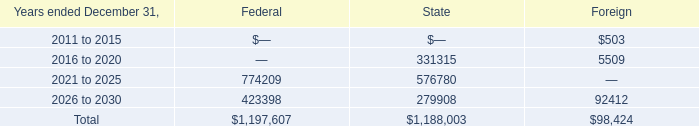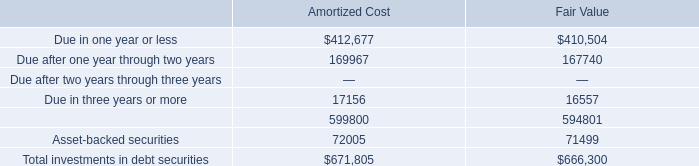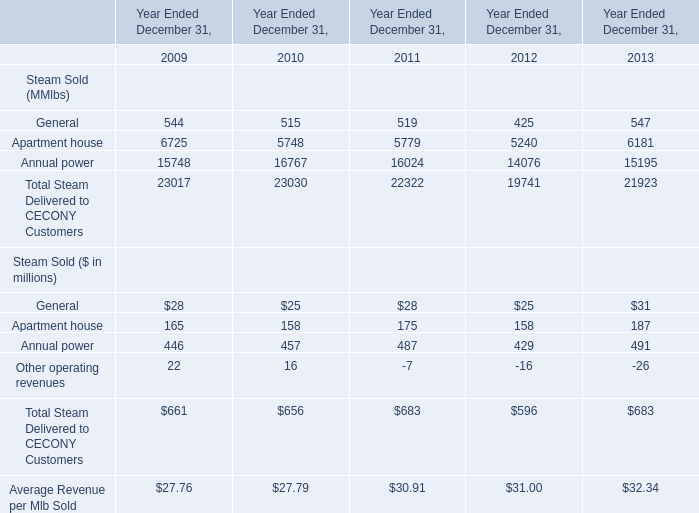what is the total net operating loss carryforwards? 
Computations: ((1197607 + 1188003) + 98424)
Answer: 2484034.0. 